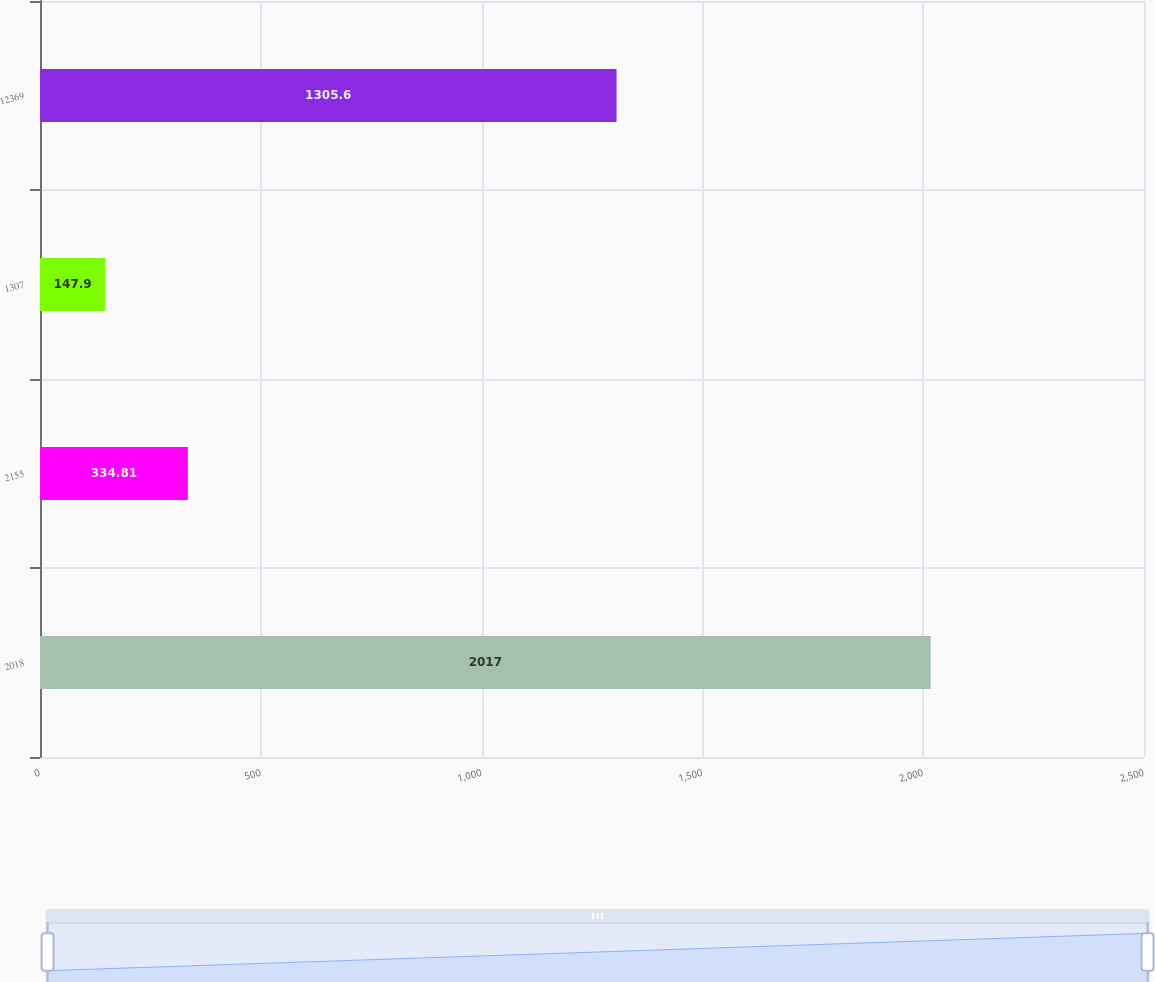<chart> <loc_0><loc_0><loc_500><loc_500><bar_chart><fcel>2018<fcel>2155<fcel>1307<fcel>12369<nl><fcel>2017<fcel>334.81<fcel>147.9<fcel>1305.6<nl></chart> 